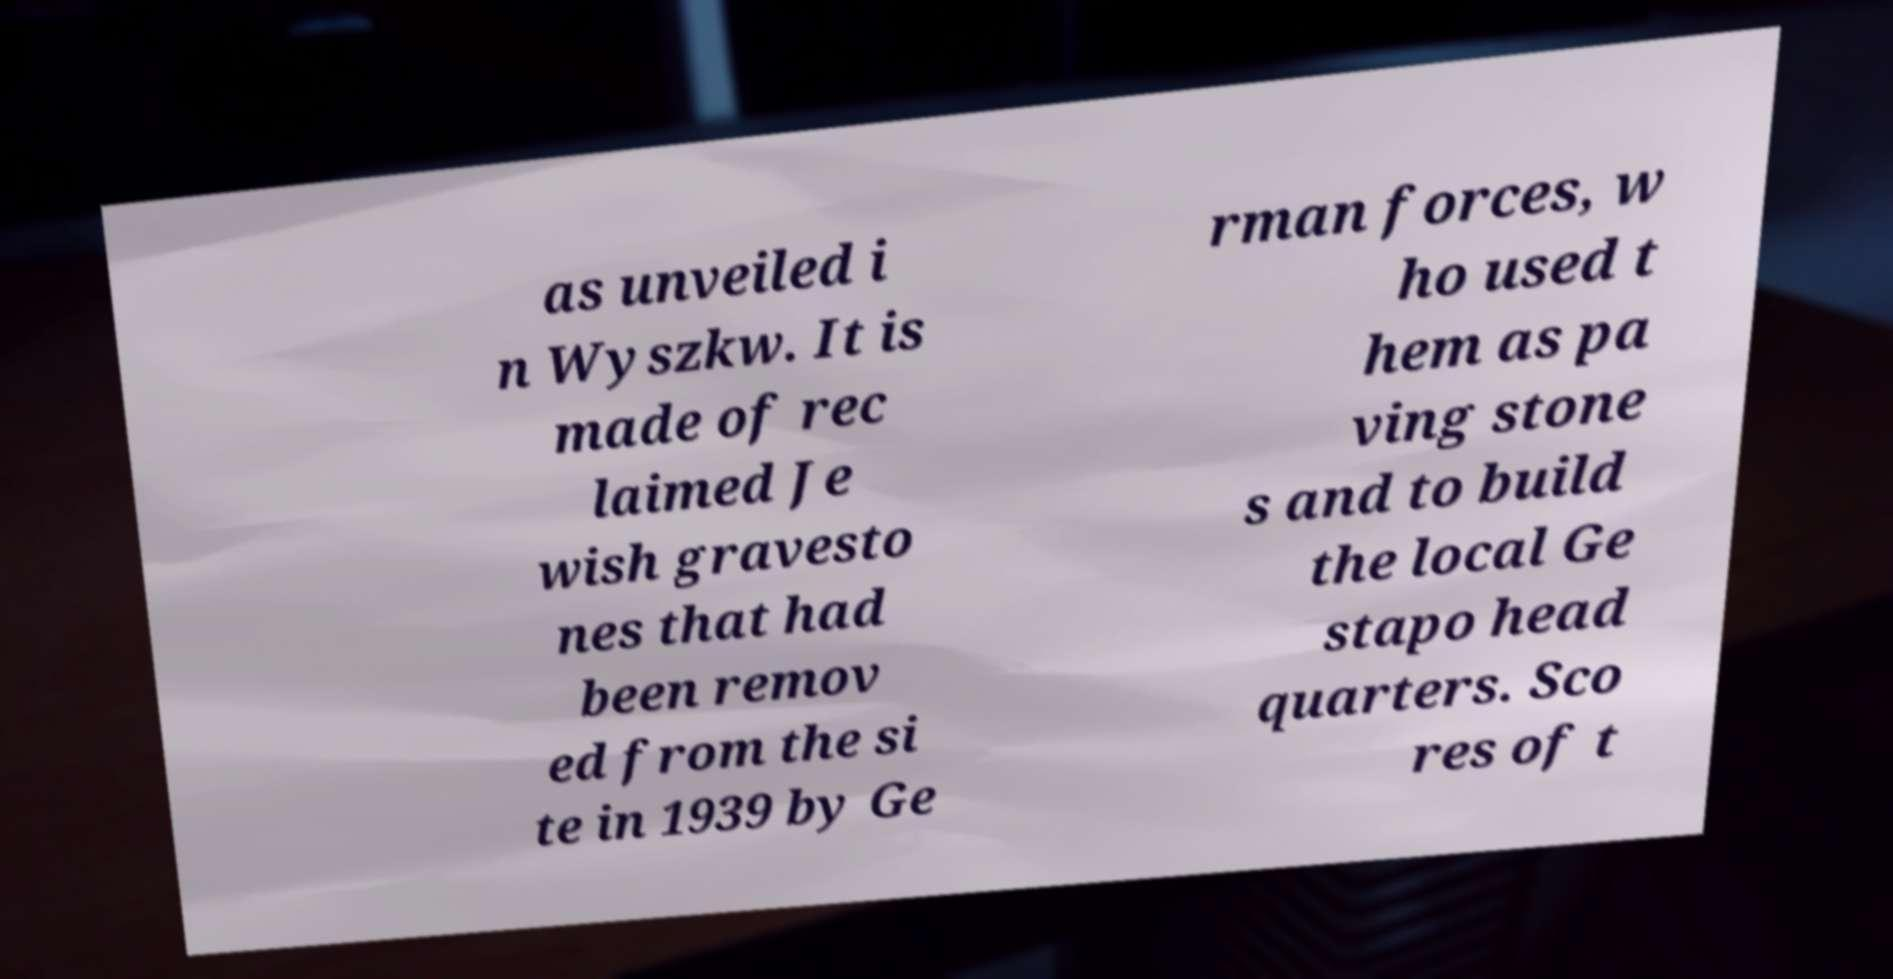Could you assist in decoding the text presented in this image and type it out clearly? as unveiled i n Wyszkw. It is made of rec laimed Je wish gravesto nes that had been remov ed from the si te in 1939 by Ge rman forces, w ho used t hem as pa ving stone s and to build the local Ge stapo head quarters. Sco res of t 